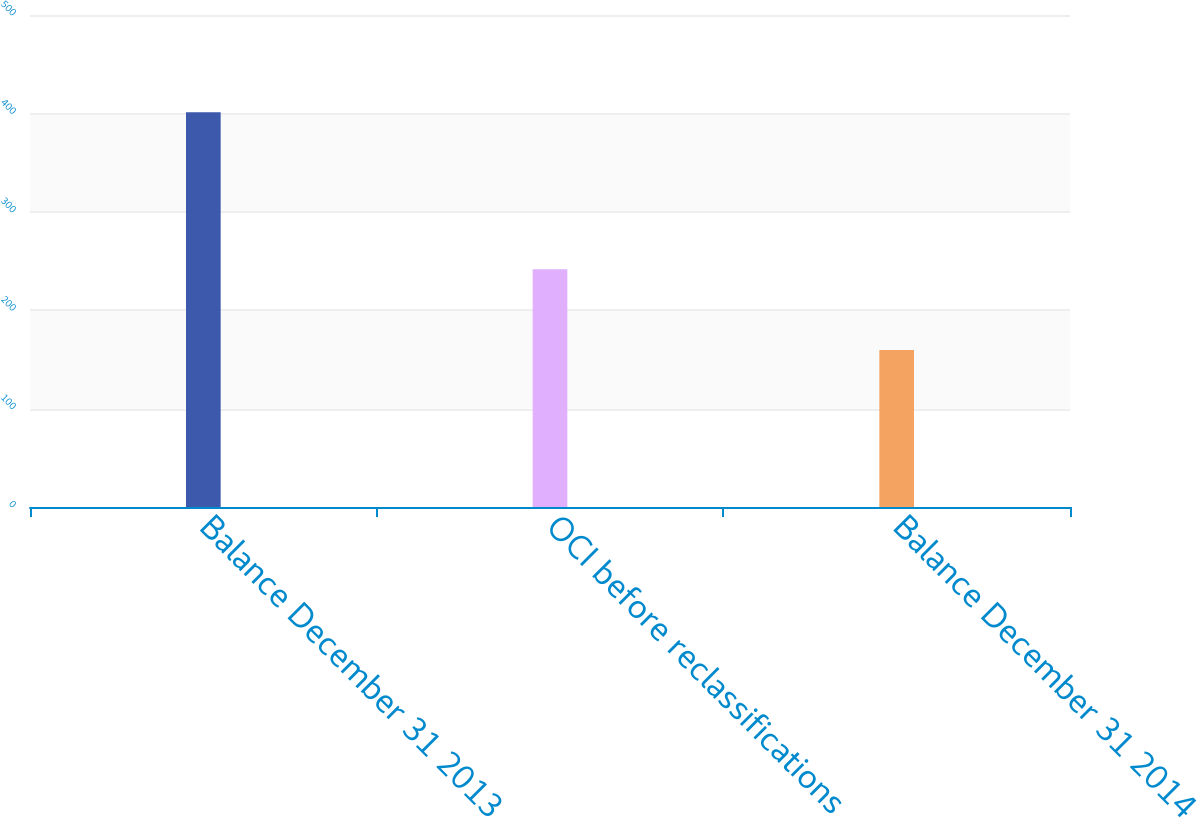<chart> <loc_0><loc_0><loc_500><loc_500><bar_chart><fcel>Balance December 31 2013<fcel>OCI before reclassifications<fcel>Balance December 31 2014<nl><fcel>401.1<fcel>241.5<fcel>159.6<nl></chart> 